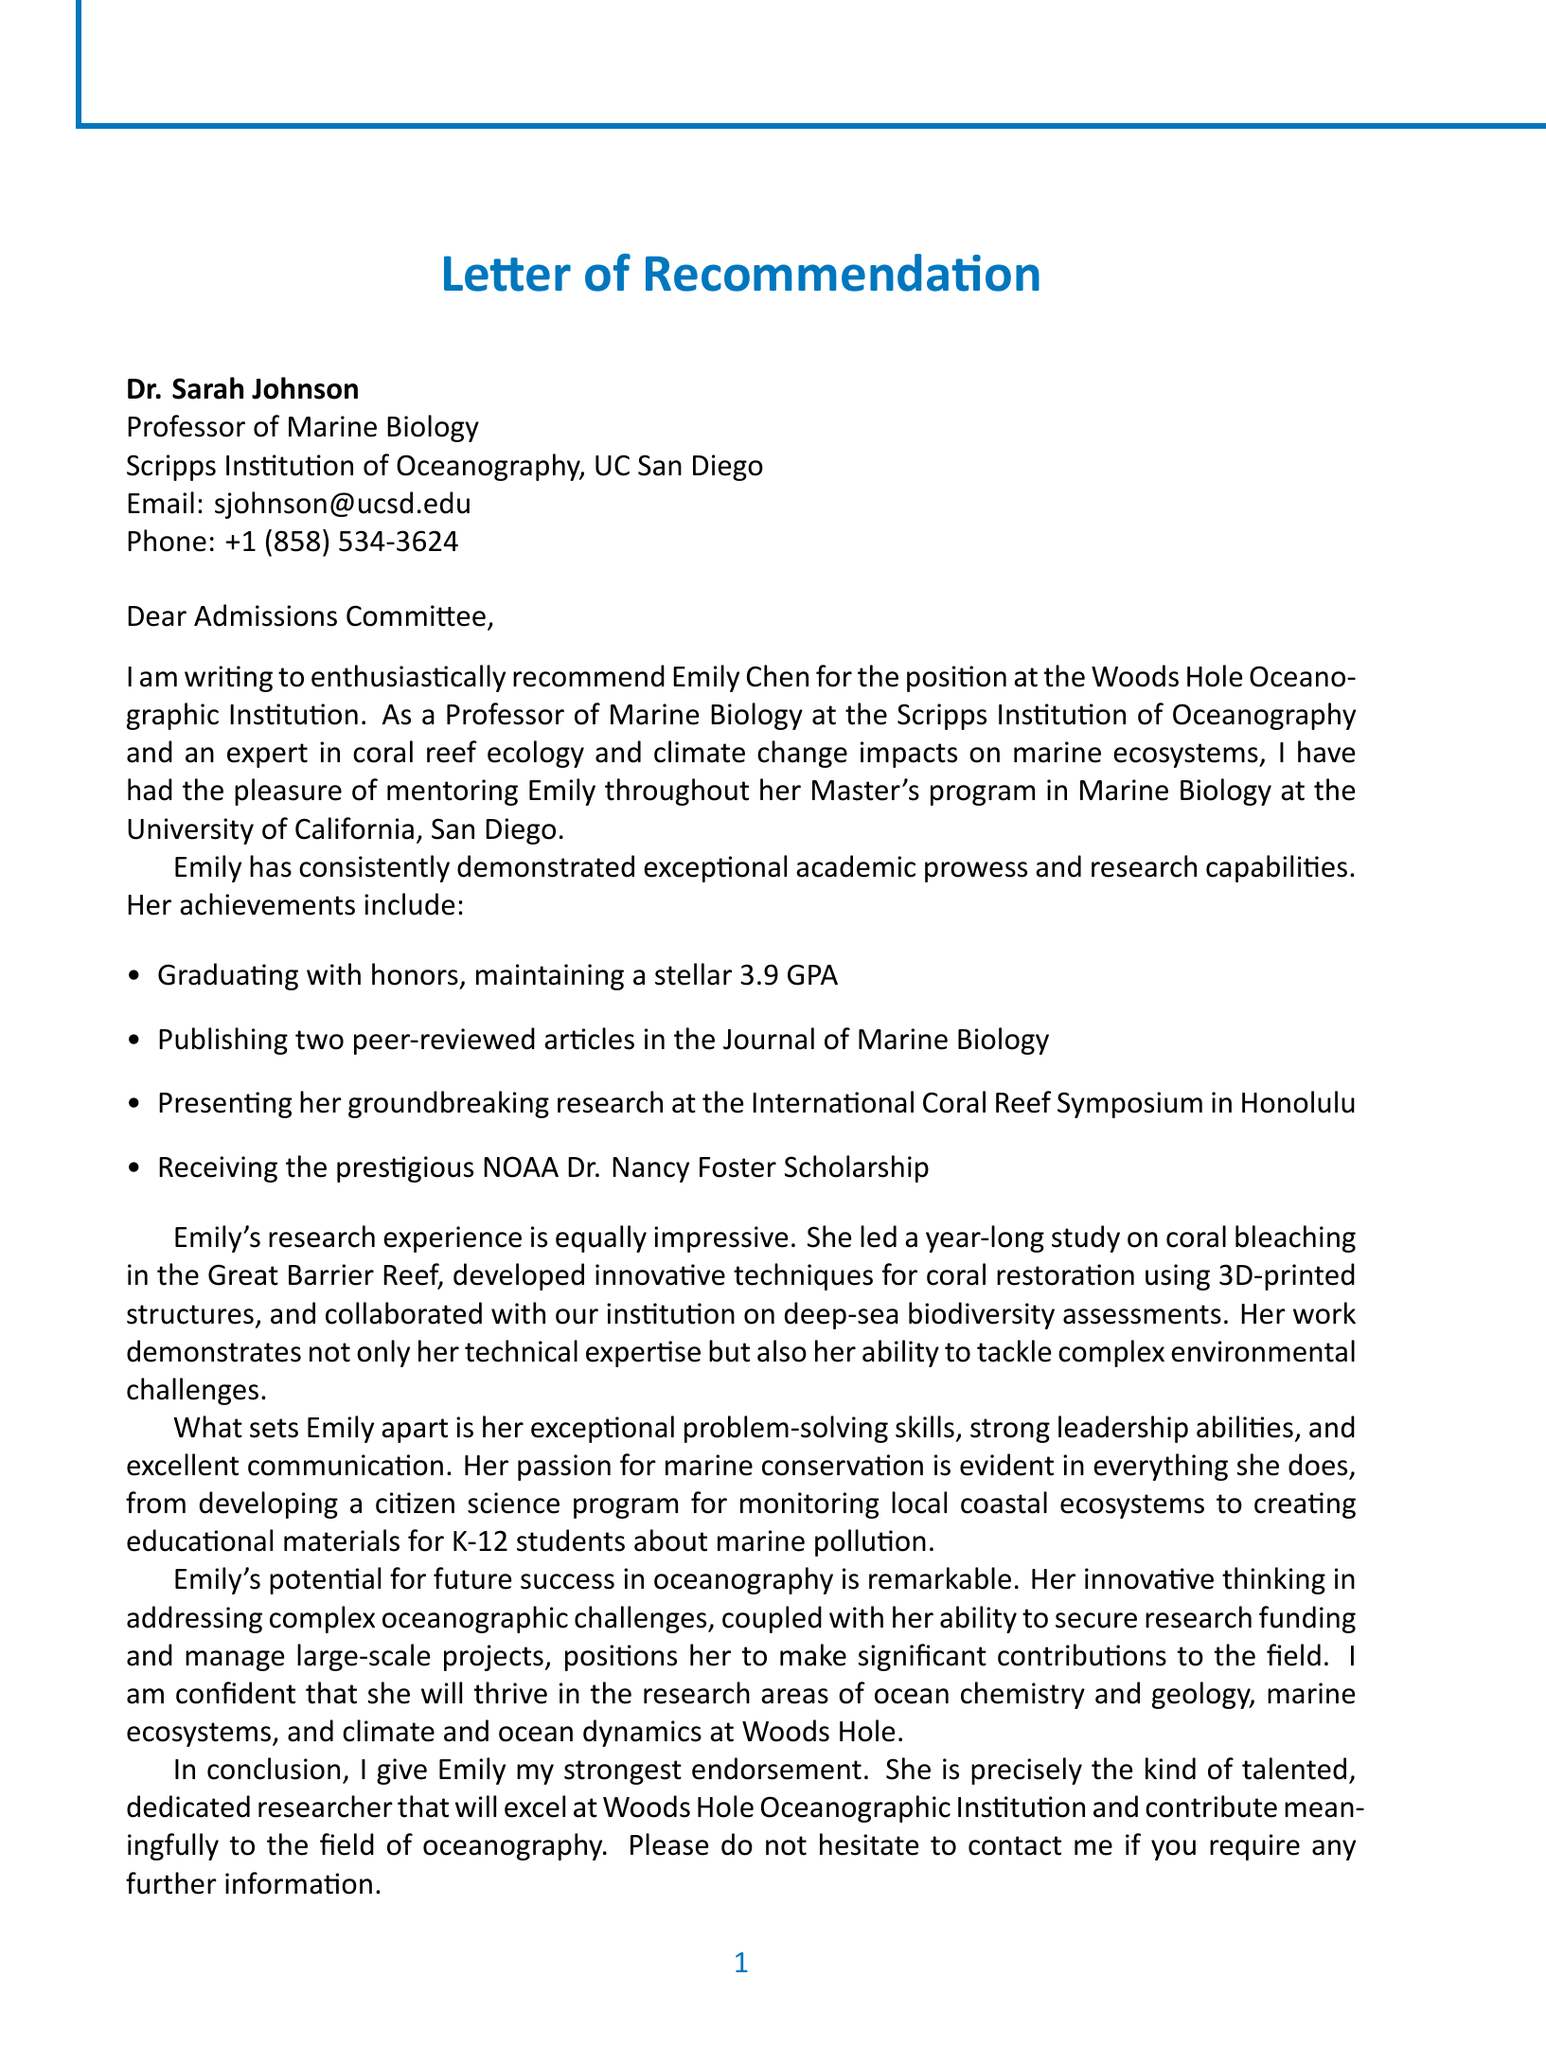what is the name of the student? The name of the student is explicitly mentioned at the beginning of the letter.
Answer: Emily Chen which scholarship did the student receive? The scholarship is listed among Emily's academic achievements.
Answer: NOAA Dr. Nancy Foster Scholarship what is the student's GPA? The student's GPA is stated in the context of her academic achievements.
Answer: 3.9 who is the writer of the letter? The author of the letter is mentioned in the signature section.
Answer: Dr. Sarah Johnson what research focus did Emily specialize in? The research focus is presented right after stating the student's degree and university.
Answer: Coral reef ecology and conservation what institution is Emily applying to? The institution where Emily is seeking a position is mentioned in the introduction.
Answer: Woods Hole Oceanographic Institution what kind of program did Emily develop for local coastal ecosystems? This is stated under Emily’s contributions to marine biology.
Answer: Citizen science program how many peer-reviewed articles has Emily published? The number of articles is stated as part of her academic achievements.
Answer: Two what qualities does Dr. Sarah Johnson attribute to Emily? The letter describes specific personal qualities that highlight Emily's characteristics.
Answer: Problem-solving skills, leadership abilities, communication, passion what is the primary field of expertise of Dr. Sarah Johnson? This information is noted in the writer's credentials section.
Answer: Coral reef ecology 